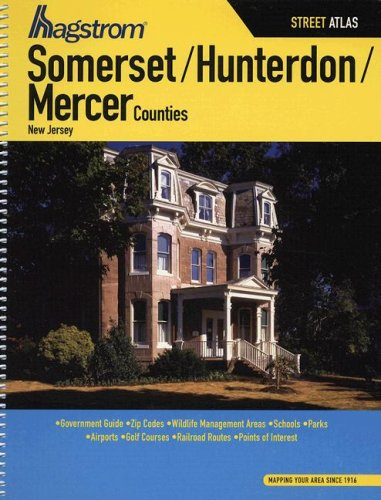What type of book is this? This is a street atlas, designed for navigating and exploring Somerset, Hunterdon, and Mercer Counties in New Jersey, incorporating maps as well as location-specific information such as parks, schools, and airports. 